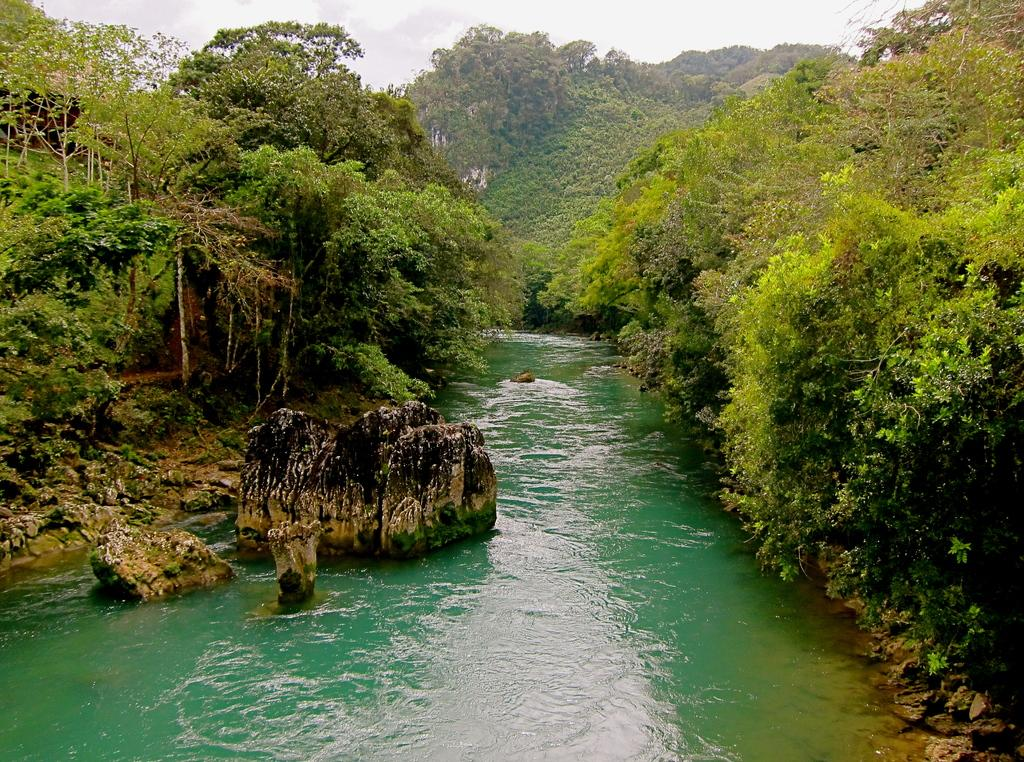What is present at the bottom of the image? There is water at the bottom of the image. What type of vegetation can be seen on the right side of the image? There are trees on the right side of the image. What type of vegetation can be seen on the left side of the image? There are trees on the left side of the image. What is visible at the top of the image? The sky is visible at the top of the image. Can you tell me how many records are stacked on the trees in the image? There are no records present in the image; it features trees and water. How many dogs can be seen playing in the water in the image? There are no dogs present in the image; it features trees and water. 